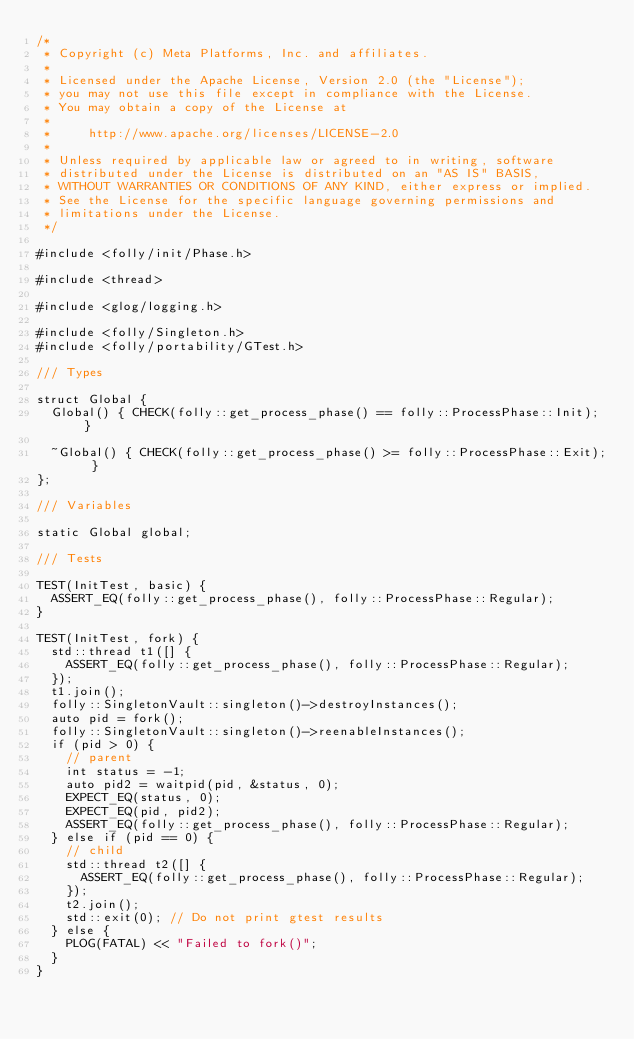Convert code to text. <code><loc_0><loc_0><loc_500><loc_500><_C++_>/*
 * Copyright (c) Meta Platforms, Inc. and affiliates.
 *
 * Licensed under the Apache License, Version 2.0 (the "License");
 * you may not use this file except in compliance with the License.
 * You may obtain a copy of the License at
 *
 *     http://www.apache.org/licenses/LICENSE-2.0
 *
 * Unless required by applicable law or agreed to in writing, software
 * distributed under the License is distributed on an "AS IS" BASIS,
 * WITHOUT WARRANTIES OR CONDITIONS OF ANY KIND, either express or implied.
 * See the License for the specific language governing permissions and
 * limitations under the License.
 */

#include <folly/init/Phase.h>

#include <thread>

#include <glog/logging.h>

#include <folly/Singleton.h>
#include <folly/portability/GTest.h>

/// Types

struct Global {
  Global() { CHECK(folly::get_process_phase() == folly::ProcessPhase::Init); }

  ~Global() { CHECK(folly::get_process_phase() >= folly::ProcessPhase::Exit); }
};

/// Variables

static Global global;

/// Tests

TEST(InitTest, basic) {
  ASSERT_EQ(folly::get_process_phase(), folly::ProcessPhase::Regular);
}

TEST(InitTest, fork) {
  std::thread t1([] {
    ASSERT_EQ(folly::get_process_phase(), folly::ProcessPhase::Regular);
  });
  t1.join();
  folly::SingletonVault::singleton()->destroyInstances();
  auto pid = fork();
  folly::SingletonVault::singleton()->reenableInstances();
  if (pid > 0) {
    // parent
    int status = -1;
    auto pid2 = waitpid(pid, &status, 0);
    EXPECT_EQ(status, 0);
    EXPECT_EQ(pid, pid2);
    ASSERT_EQ(folly::get_process_phase(), folly::ProcessPhase::Regular);
  } else if (pid == 0) {
    // child
    std::thread t2([] {
      ASSERT_EQ(folly::get_process_phase(), folly::ProcessPhase::Regular);
    });
    t2.join();
    std::exit(0); // Do not print gtest results
  } else {
    PLOG(FATAL) << "Failed to fork()";
  }
}
</code> 